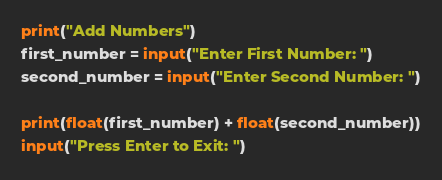<code> <loc_0><loc_0><loc_500><loc_500><_Python_>print("Add Numbers")
first_number = input("Enter First Number: ")
second_number = input("Enter Second Number: ")

print(float(first_number) + float(second_number))
input("Press Enter to Exit: ")</code> 